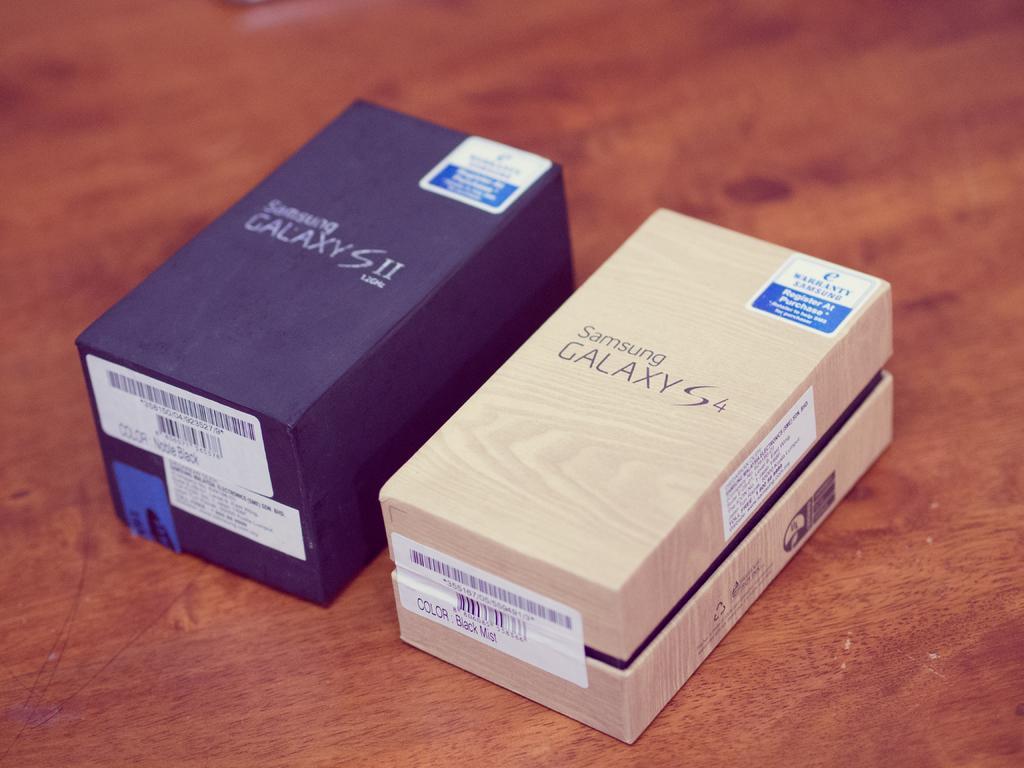Please provide a concise description of this image. We can see boxes on the wooden surface and we can see stickers on these boxes. 